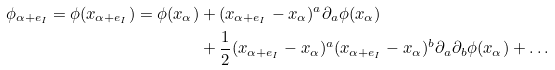<formula> <loc_0><loc_0><loc_500><loc_500>\phi _ { \alpha + e _ { I } } = \phi ( x _ { \alpha + e _ { I } } ) = \phi ( x _ { \alpha } ) & + ( x _ { \alpha + e _ { I } } - x _ { \alpha } ) ^ { a } \partial _ { a } \phi ( x _ { \alpha } ) \\ & + \frac { 1 } { 2 } ( x _ { \alpha + e _ { I } } - x _ { \alpha } ) ^ { a } ( x _ { \alpha + e _ { I } } - x _ { \alpha } ) ^ { b } \partial _ { a } \partial _ { b } \phi ( x _ { \alpha } ) + \dots</formula> 